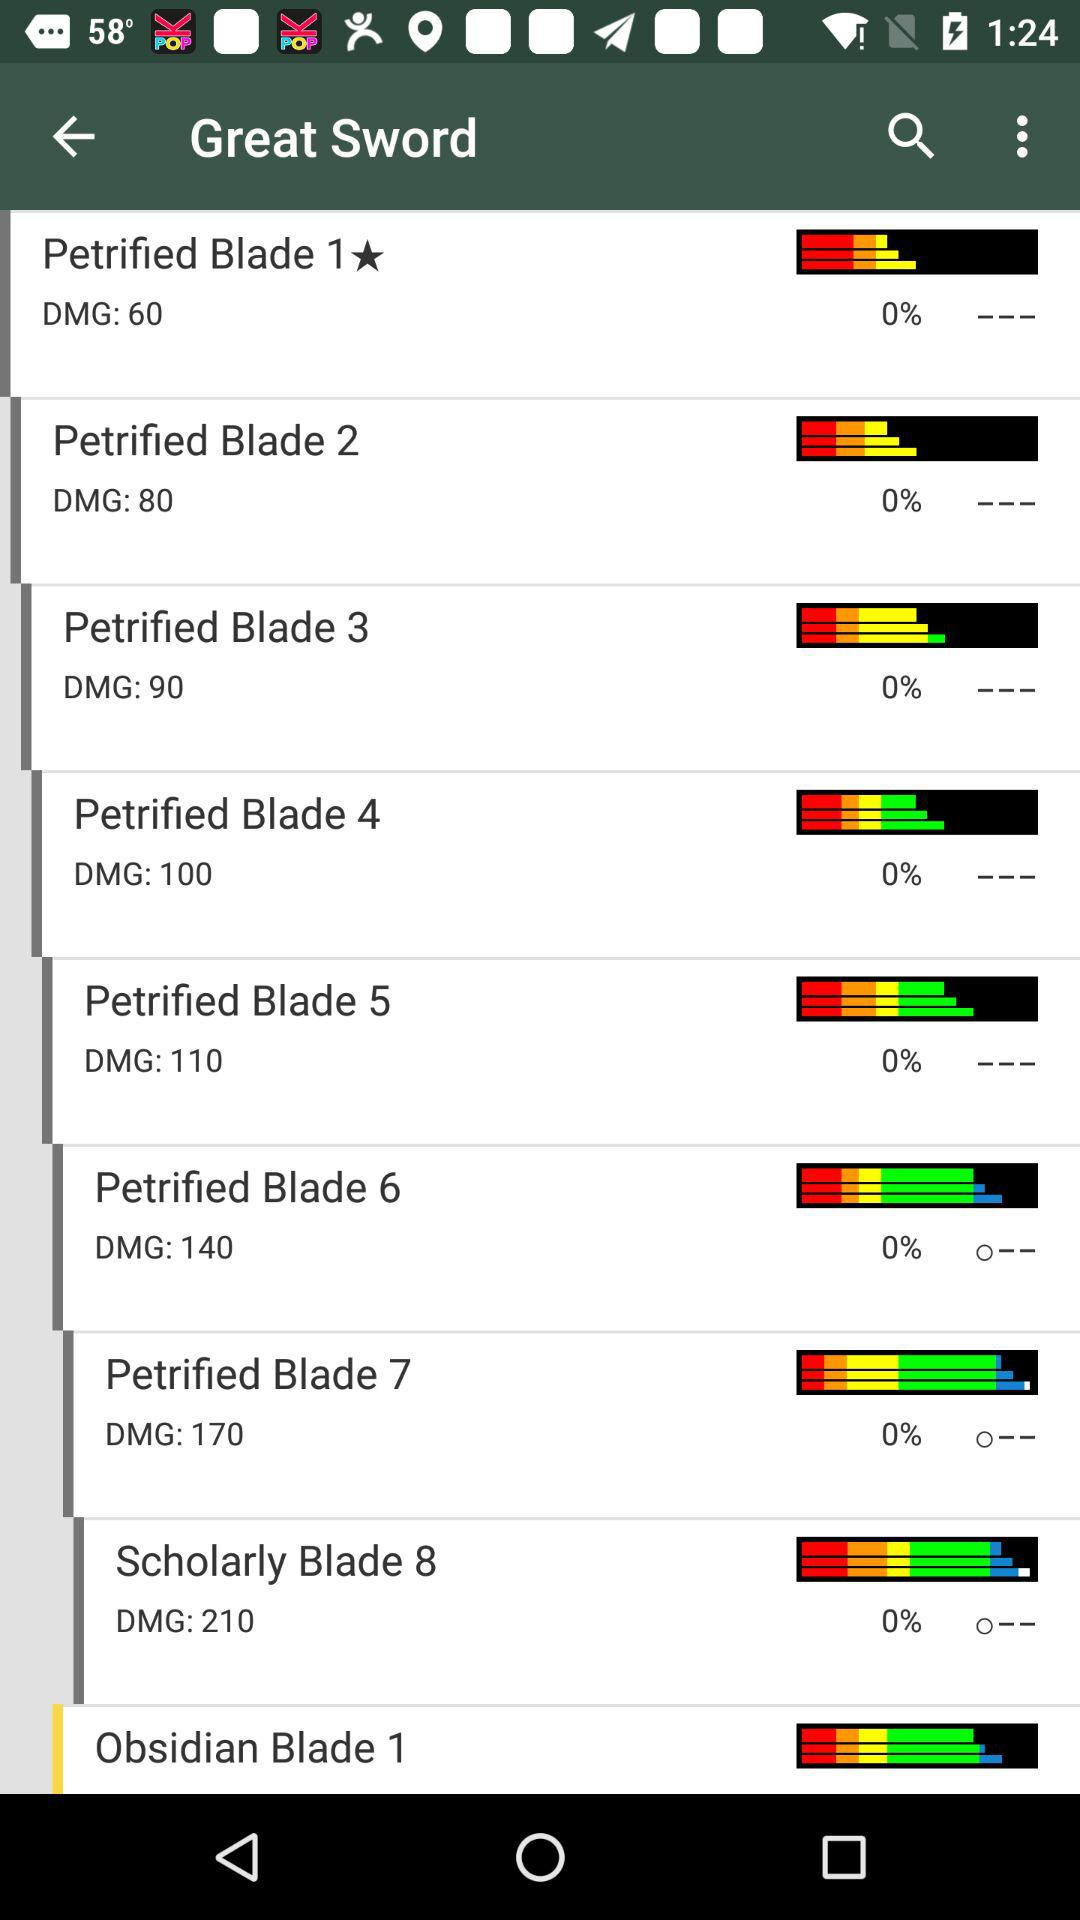What is the DMG number of "Petrified Blade 1"? The DMG number of "Petrified Blade 1" is 60. 